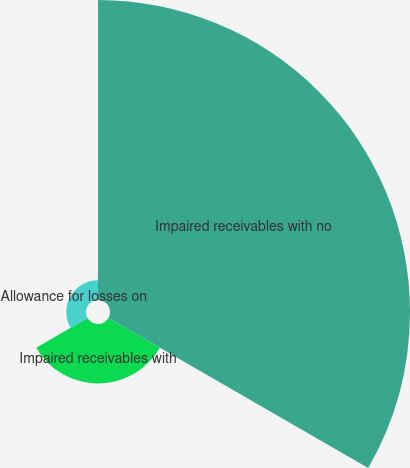Convert chart. <chart><loc_0><loc_0><loc_500><loc_500><pie_chart><fcel>Impaired receivables with no<fcel>Impaired receivables with<fcel>Allowance for losses on<nl><fcel>79.12%<fcel>15.66%<fcel>5.22%<nl></chart> 